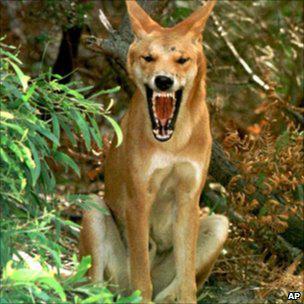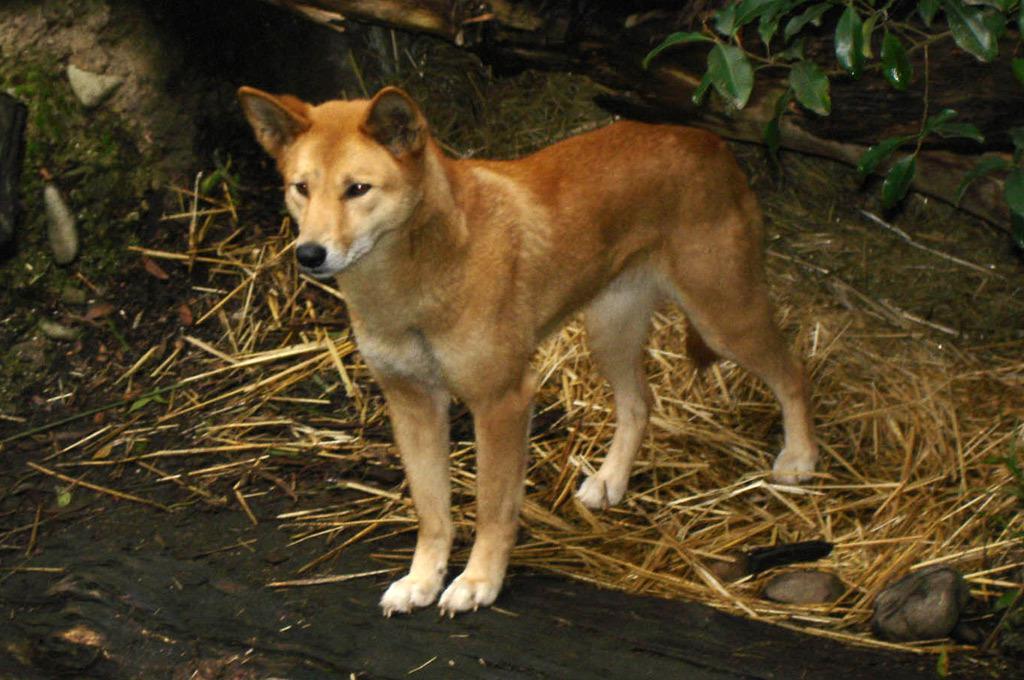The first image is the image on the left, the second image is the image on the right. For the images displayed, is the sentence "There are at most three dingoes." factually correct? Answer yes or no. Yes. The first image is the image on the left, the second image is the image on the right. Assess this claim about the two images: "The combined images contain five dingos, and at least one dingo is reclining.". Correct or not? Answer yes or no. No. 